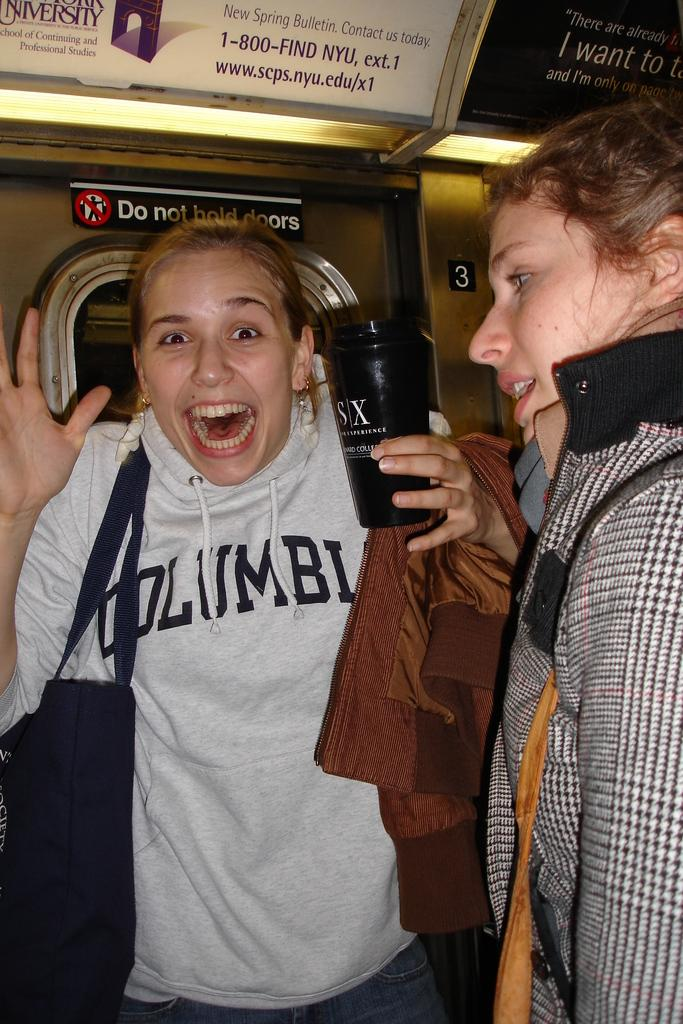How many people are in the image? There are people in the image. What are the people wearing? The people are wearing bags. Can you describe the actions of the people in the image? One person is holding an object, and another person is wearing a coat. What can be seen in the background of the image? There are boards in the background of the image, and there is text visible on the boards. What type of bottle is being used as a prop on the stage in the image? There is no stage or bottle present in the image. Is there a lamp illuminating the scene in the image? There is no lamp visible in the image. 